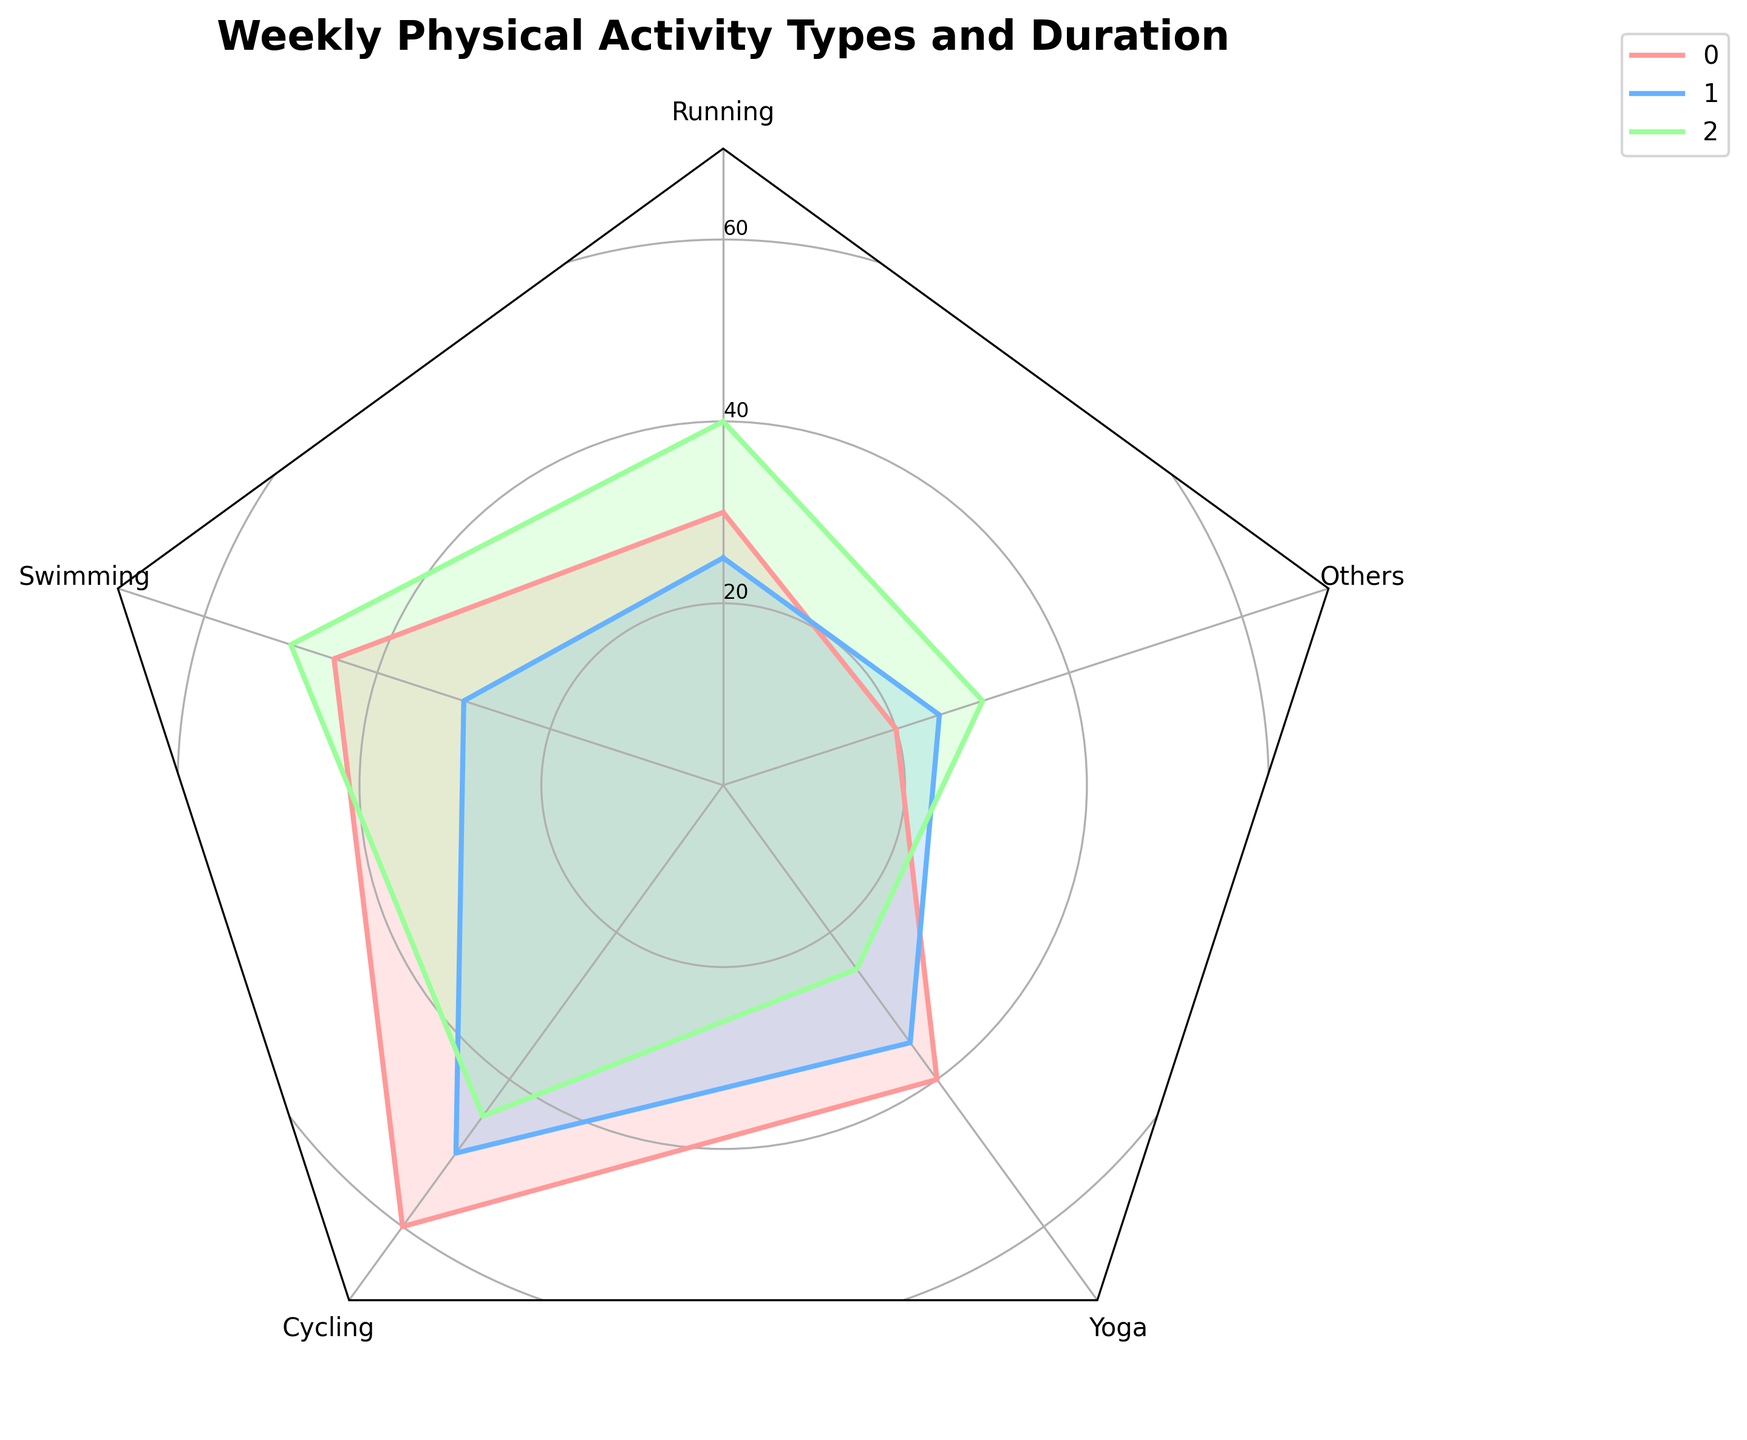Which activity type did Aaron spend the most time on? Aaron spent the most time on Cycling. To find this, note the peak value in Aaron's plot segment.
Answer: Cycling What is the total duration of physical activities Aaron engaged in? Sum the durations for Running, Swimming, Cycling, Yoga, and Others for Aaron: 30 + 45 + 60 + 40 + 20 = 195 minutes.
Answer: 195 minutes Which activity type sees the largest difference between Aaron and You? The largest difference is in Swimming. To determine this, calculate the differences for all activities: Running (5), Swimming (15), Cycling (10), Yoga (5), Others (5).
Answer: Swimming Who's the most balanced in terms of activity durations? Mutual_Friend_1 is the most balanced, with closer values among activities. They range between 25 and 50 minutes.
Answer: Mutual_Friend_1 Which activity type is Aaron least involved in? Aaron spends the least time on Others. The lowest value in Aaron's segment is for Others: 20 minutes.
Answer: Others Who spent more total time on Running and Cycling combined: You or Aaron? Add Running and Cycling times for both: Aaron (30 + 60 = 90), You (25 + 50 = 75). Aaron spent more time.
Answer: Aaron How does the time spent on Yoga compare between Aaron and Mutual_Friend_1? Aaron spends more time on Yoga than Mutual_Friend_1. Aaron spends 40 minutes, while Mutual_Friend_1 spends 25 minutes.
Answer: Aaron What is the average duration of activities for Mutual_Friend_1? Calculate the average by summing all values and dividing by the number of activities: (40 + 50 + 45 + 25 + 30) / 5 = 190 / 5 = 38 minutes.
Answer: 38 minutes Which activity's duration for Aaron is closest to the average duration for Mutual_Friend_1? Aaron's Yoga duration, 40 minutes, is closest to Mutual_Friend_1's average of 38 minutes. Compare Aaron's activity durations to Mutual_Friend_1's average.
Answer: Yoga In which activity type is the duration difference between You and Mutual_Friend_1 the smallest? The smallest difference is in Others. Compare the differences for all activities: Running (15), Swimming (20), Cycling (5), Yoga (10), Others (5).
Answer: Others 